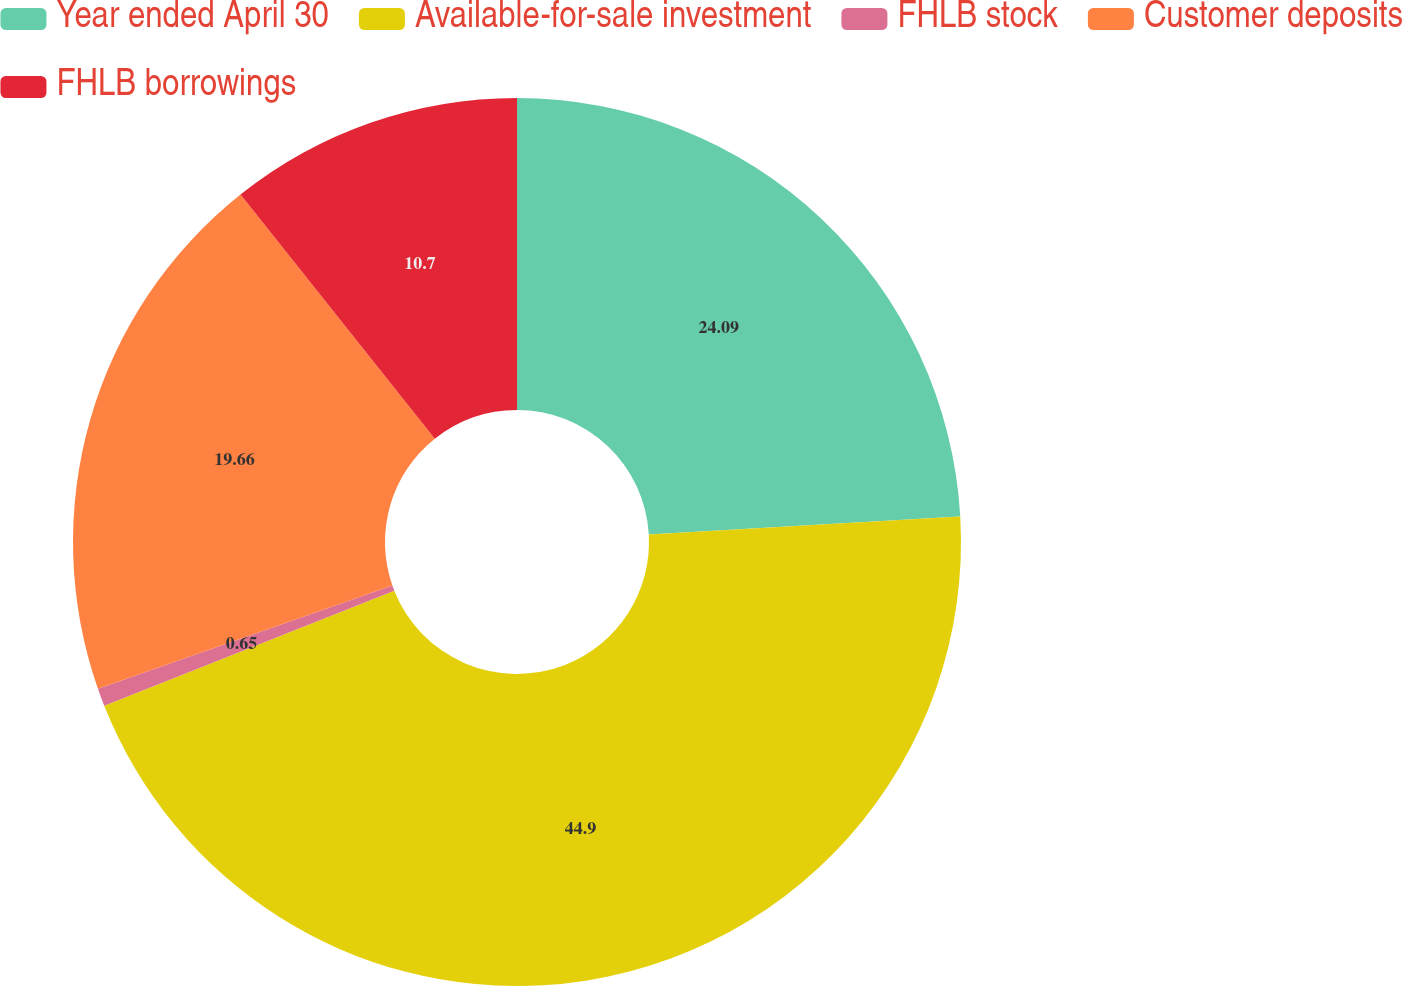<chart> <loc_0><loc_0><loc_500><loc_500><pie_chart><fcel>Year ended April 30<fcel>Available-for-sale investment<fcel>FHLB stock<fcel>Customer deposits<fcel>FHLB borrowings<nl><fcel>24.09%<fcel>44.91%<fcel>0.65%<fcel>19.66%<fcel>10.7%<nl></chart> 